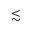<formula> <loc_0><loc_0><loc_500><loc_500>\lesssim</formula> 